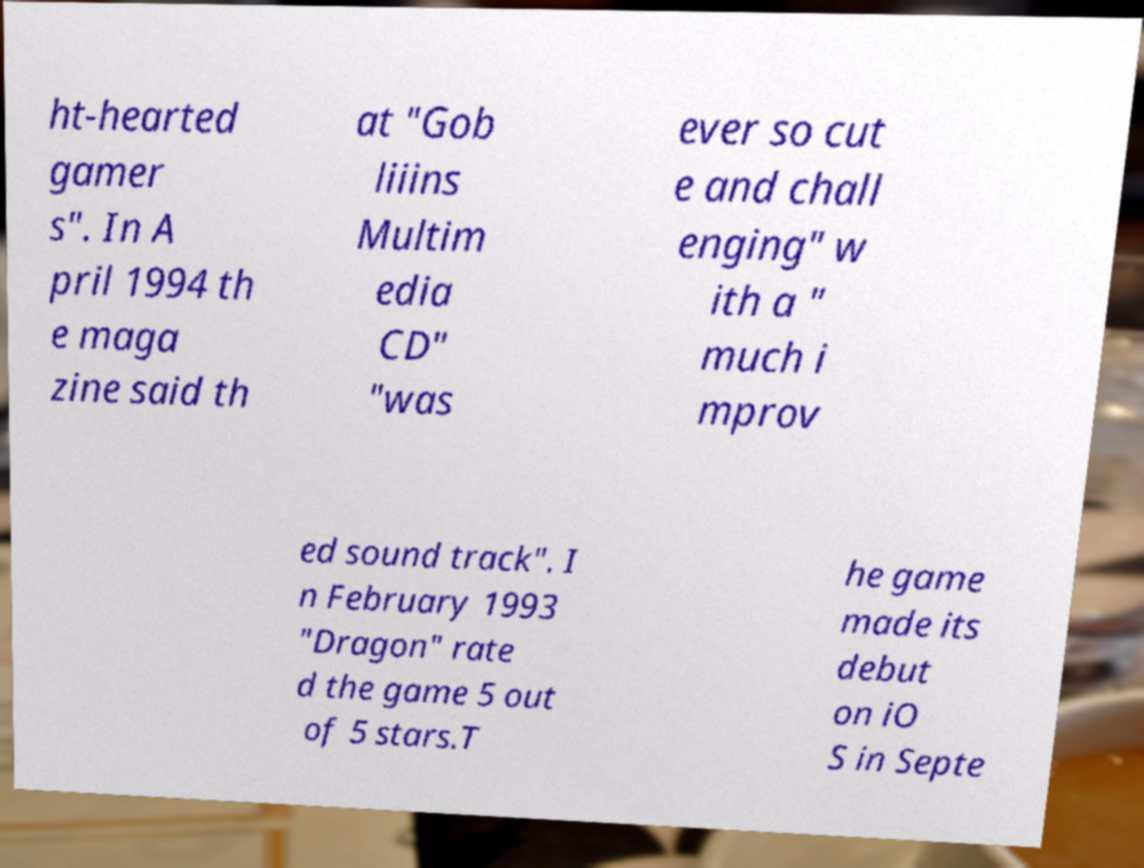Could you assist in decoding the text presented in this image and type it out clearly? ht-hearted gamer s". In A pril 1994 th e maga zine said th at "Gob liiins Multim edia CD" "was ever so cut e and chall enging" w ith a " much i mprov ed sound track". I n February 1993 "Dragon" rate d the game 5 out of 5 stars.T he game made its debut on iO S in Septe 